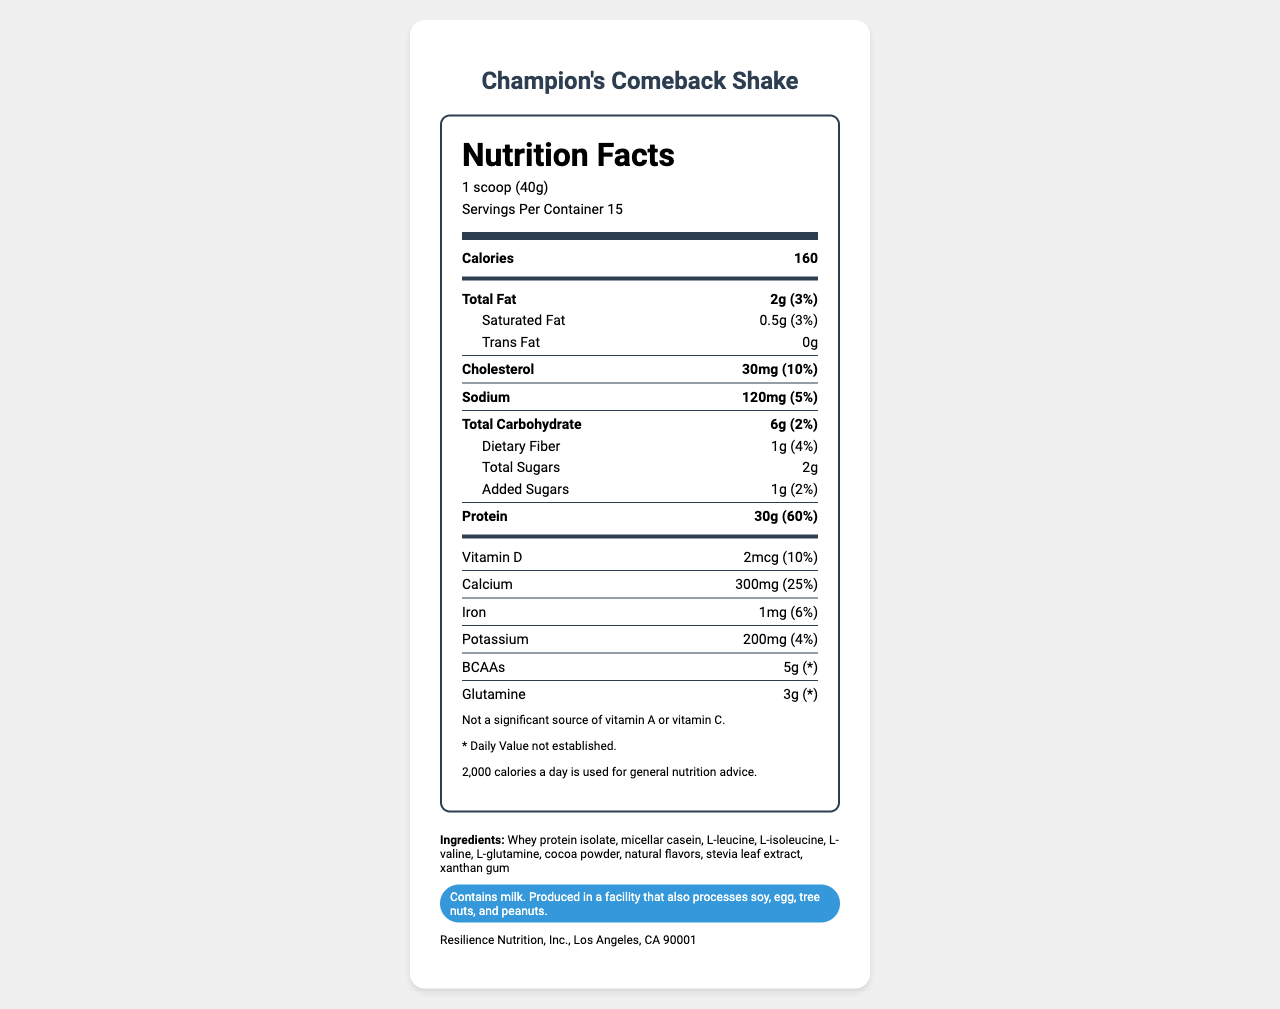What is the serving size for Champion's Comeback Shake? The serving size information is explicitly listed in the Nutrition Facts section under "Serving Size."
Answer: 1 scoop (40g) How many servings are in one container of Champion's Comeback Shake? The number of servings per container is specified in the Nutrition Facts section as "Servings Per Container: 15."
Answer: 15 servings How much protein does one serving of Champion's Comeback Shake provide? The protein content per serving is clearly mentioned in the Nutrition Facts under "Protein."
Answer: 30g What is the daily value percentage of calcium in one serving? The daily value percentage of calcium is provided in the Nutrition Facts under "Calcium."
Answer: 25% What ingredients are included in Champion's Comeback Shake? The ingredients are listed at the bottom of the document under "Ingredients."
Answer: Whey protein isolate, micellar casein, L-leucine, L-isoleucine, L-valine, L-glutamine, cocoa powder, natural flavors, stevia leaf extract, xanthan gum How many total carbohydrates are in one serving? A. 2g B. 6g C. 1g The total carbohydrates per serving are stated in the Nutrition Facts section as "Total Carbohydrate: 6g."
Answer: B. 6g What is the amount of cholesterol in one serving? A. 10mg B. 20mg C. 30mg D. 40mg The amount of cholesterol per serving is listed in the Nutrition Facts under "Cholesterol."
Answer: C. 30mg Does Champion's Comeback Shake contain any trans fat? The document specifies "Trans Fat: 0g" in the Nutrition Facts.
Answer: No Is Champion's Comeback Shake a significant source of vitamin A? The claim statement at the end mentions, "Not a significant source of vitamin A."
Answer: No Summarize the main nutrition facts of Champion's Comeback Shake. The summary includes key nutritional details provided in the Nutrition Facts section, emphasizing the primary contents and their significance.
Answer: Champion's Comeback Shake provides 160 calories per serving with 2g of total fat. Each serving includes 30g of protein, 6g of carbohydrates, and notable amounts of calcium (300mg). The product also contains BCAAs (5g) and glutamine (3g). What is the fiber content per serving of Champion's Comeback Shake? The amount of dietary fiber per serving is listed under "Dietary Fiber" in the Nutrition Facts.
Answer: 1g Which company manufactures Champion's Comeback Shake? The name of the manufacturer is provided at the end of the document under "Manufacturer Info."
Answer: Resilience Nutrition, Inc. Does the Champion's Comeback Shake contain any allergens? The allergen information specifies that the product contains milk and is produced in a facility that also processes soy, egg, tree nuts, and peanuts.
Answer: Yes What is the daily value of Vitamin D provided by one serving? The daily value percentage of Vitamin D is listed in the Nutrition Facts under "Vitamin D."
Answer: 10% Is there any potassium content in the shake? The Nutrition Facts indicate that there is 200mg of potassium per serving, with a daily value percentage of 4%.
Answer: Yes What flavors are used in the Champion's Comeback Shake? The "Ingredients" section lists natural flavors as one of the components.
Answer: Natural flavors How much total fat is in one serving? The amount of total fat per serving is explicitly listed in the Nutrition Facts.
Answer: 2g What is the specific location of the manufacturing company? The address of the manufacturer is provided at the end of the document under "Manufacturer Info."
Answer: Los Angeles, CA 90001 What is the daily value of iron in one serving? The percentage of daily value for iron is listed in the Nutrition Facts under "Iron."
Answer: 6% Does this shake provide significant Vitamin C? The claim statement at the end mentions, "Not a significant source of Vitamin C."
Answer: No How many calories are recommended for general nutrition advice? The calorie conversion note at the end states that 2,000 calories a day is used for general nutrition advice.
Answer: 2,000 calories What amino acids are specifically added to the Champion's Comeback Shake? The specific amino acids are listed in the "Ingredients" section.
Answer: L-leucine, L-isoleucine, L-valine, L-glutamine Why is the BCAA and glutamine daily value not established? The document includes a footnote stating, "Daily Value not established," but it doesn't provide a reason for this.
Answer: I don't know 